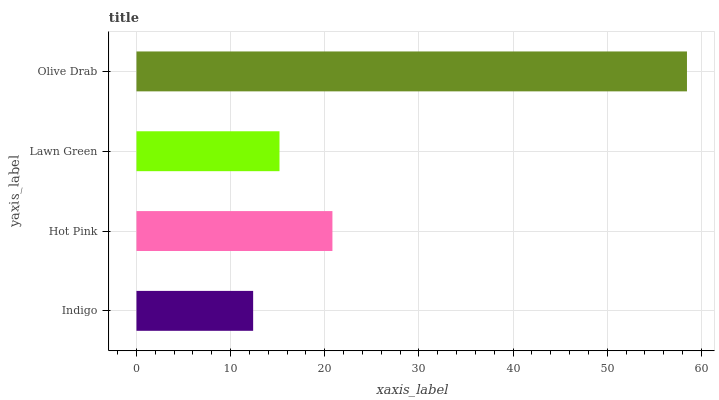Is Indigo the minimum?
Answer yes or no. Yes. Is Olive Drab the maximum?
Answer yes or no. Yes. Is Hot Pink the minimum?
Answer yes or no. No. Is Hot Pink the maximum?
Answer yes or no. No. Is Hot Pink greater than Indigo?
Answer yes or no. Yes. Is Indigo less than Hot Pink?
Answer yes or no. Yes. Is Indigo greater than Hot Pink?
Answer yes or no. No. Is Hot Pink less than Indigo?
Answer yes or no. No. Is Hot Pink the high median?
Answer yes or no. Yes. Is Lawn Green the low median?
Answer yes or no. Yes. Is Lawn Green the high median?
Answer yes or no. No. Is Indigo the low median?
Answer yes or no. No. 